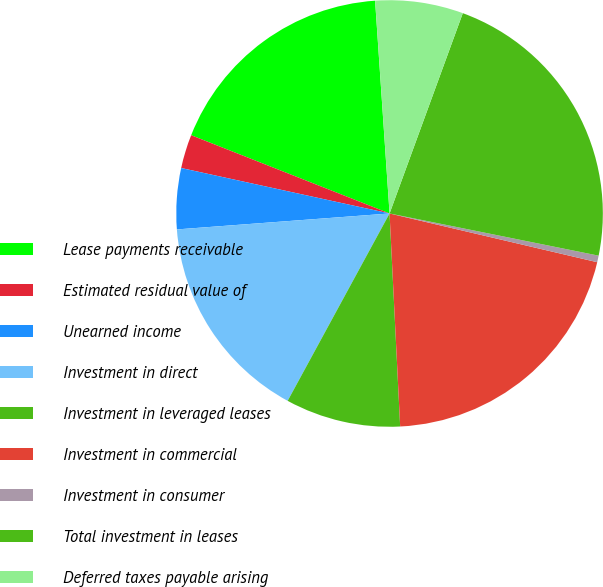Convert chart. <chart><loc_0><loc_0><loc_500><loc_500><pie_chart><fcel>Lease payments receivable<fcel>Estimated residual value of<fcel>Unearned income<fcel>Investment in direct<fcel>Investment in leveraged leases<fcel>Investment in commercial<fcel>Investment in consumer<fcel>Total investment in leases<fcel>Deferred taxes payable arising<nl><fcel>17.94%<fcel>2.56%<fcel>4.61%<fcel>15.88%<fcel>8.72%<fcel>20.54%<fcel>0.5%<fcel>22.59%<fcel>6.66%<nl></chart> 